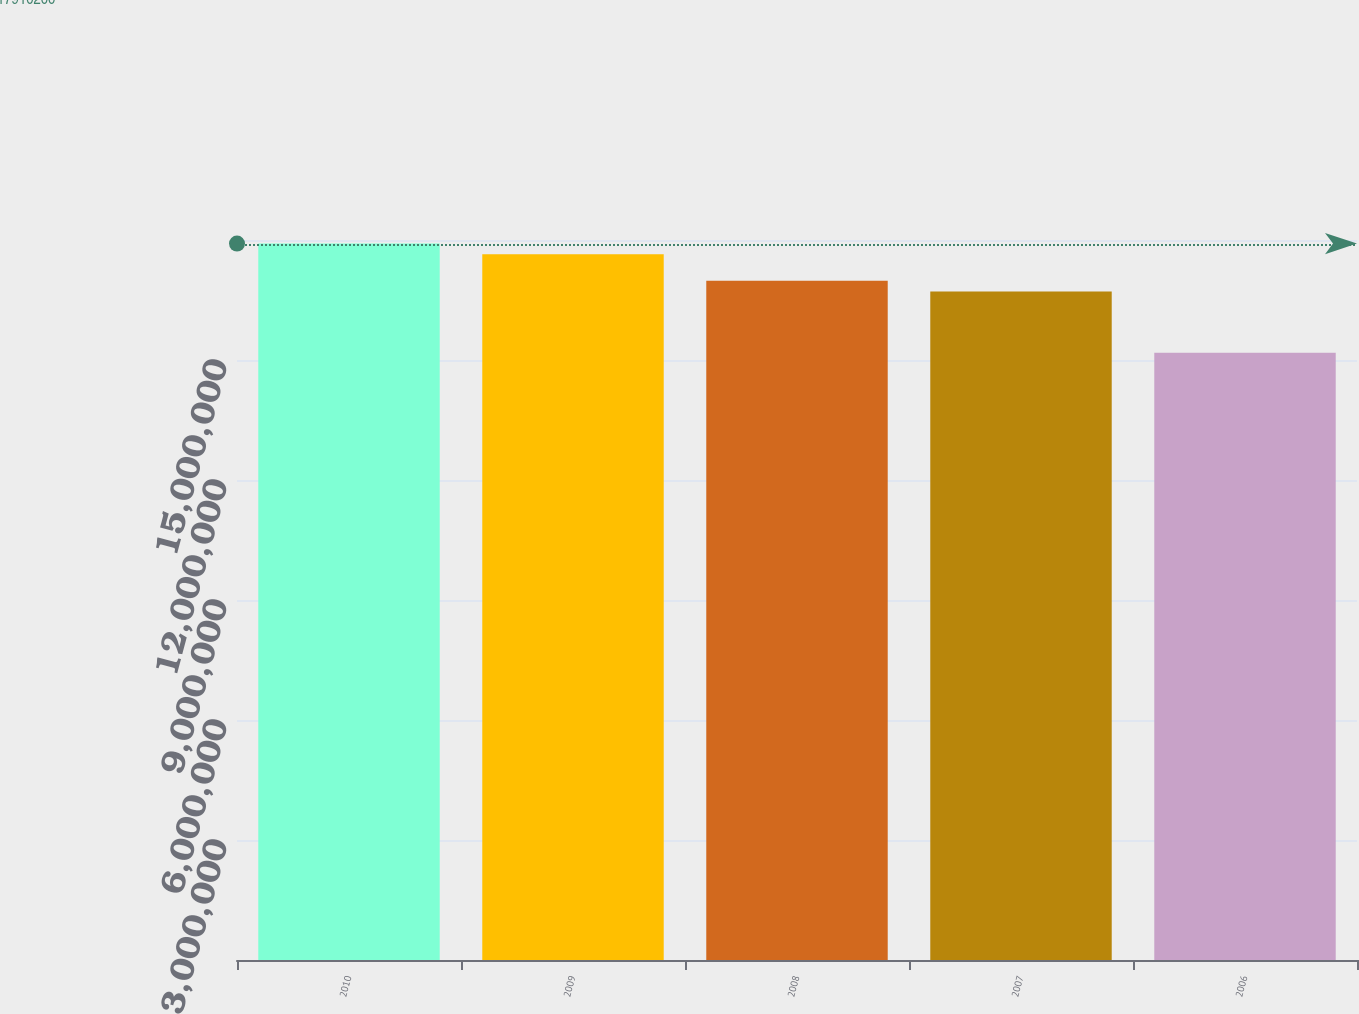Convert chart to OTSL. <chart><loc_0><loc_0><loc_500><loc_500><bar_chart><fcel>2010<fcel>2009<fcel>2008<fcel>2007<fcel>2006<nl><fcel>1.79102e+07<fcel>1.7646e+07<fcel>1.6981e+07<fcel>1.6715e+07<fcel>1.5181e+07<nl></chart> 